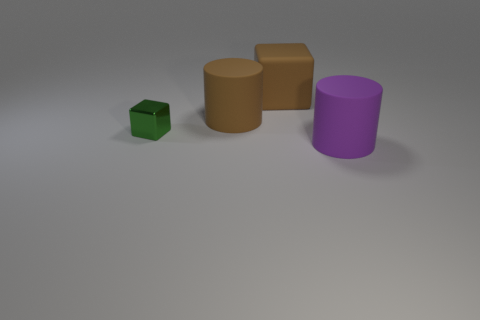Add 2 small gray metal cylinders. How many objects exist? 6 Subtract 0 yellow spheres. How many objects are left? 4 Subtract all brown matte cylinders. Subtract all large matte cylinders. How many objects are left? 1 Add 4 big purple things. How many big purple things are left? 5 Add 4 large purple objects. How many large purple objects exist? 5 